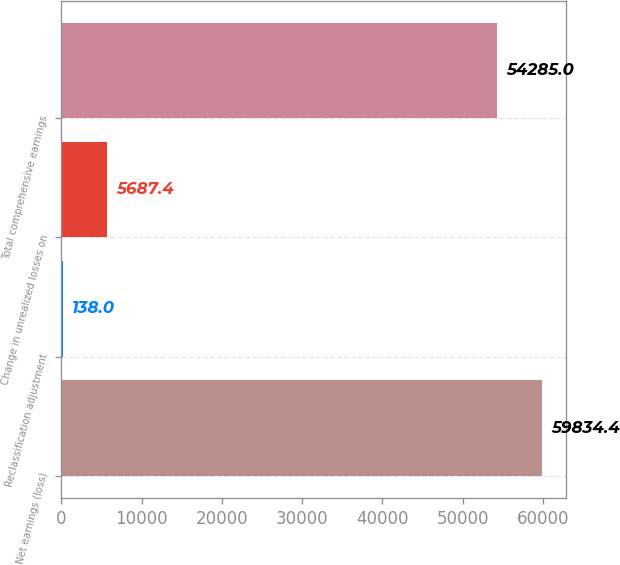Convert chart to OTSL. <chart><loc_0><loc_0><loc_500><loc_500><bar_chart><fcel>Net earnings (loss)<fcel>Reclassification adjustment<fcel>Change in unrealized losses on<fcel>Total comprehensive earnings<nl><fcel>59834.4<fcel>138<fcel>5687.4<fcel>54285<nl></chart> 